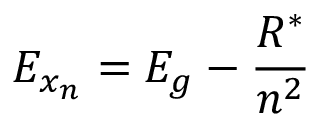Convert formula to latex. <formula><loc_0><loc_0><loc_500><loc_500>E _ { x _ { n } } = E _ { g } - \frac { R ^ { * } } { n ^ { 2 } }</formula> 